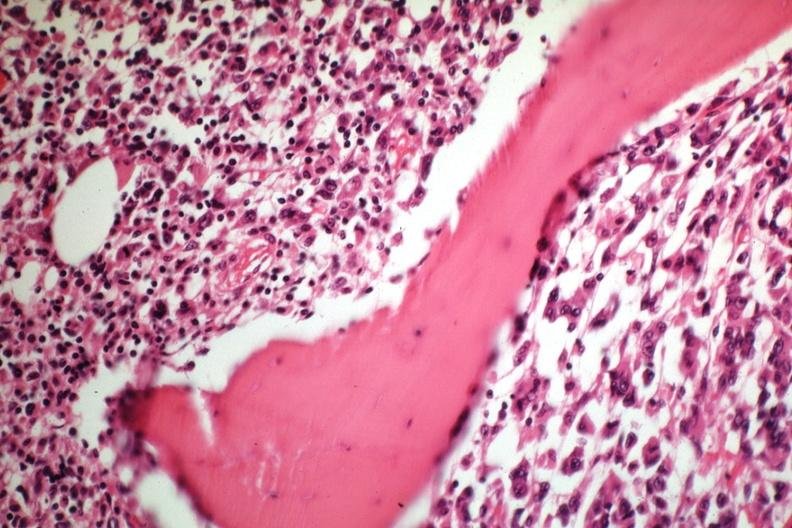what is slide?
Answer the question using a single word or phrase. Tumor well shown gross 